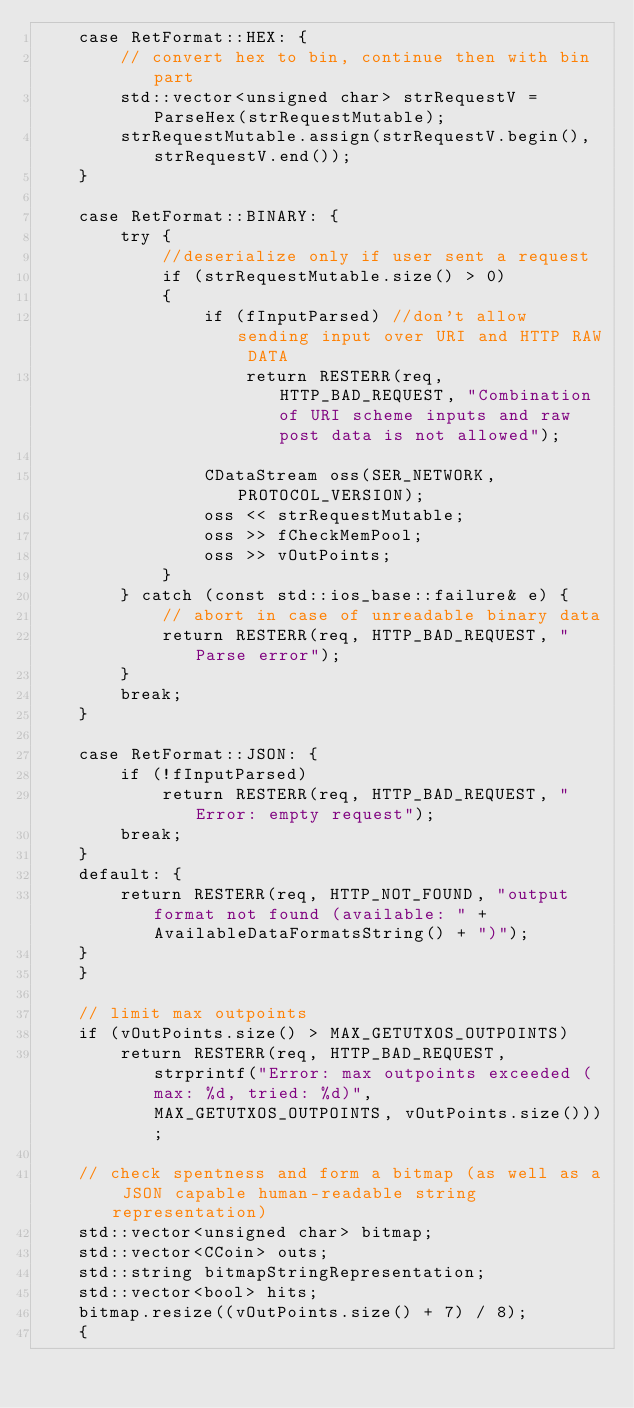<code> <loc_0><loc_0><loc_500><loc_500><_C++_>    case RetFormat::HEX: {
        // convert hex to bin, continue then with bin part
        std::vector<unsigned char> strRequestV = ParseHex(strRequestMutable);
        strRequestMutable.assign(strRequestV.begin(), strRequestV.end());
    }

    case RetFormat::BINARY: {
        try {
            //deserialize only if user sent a request
            if (strRequestMutable.size() > 0)
            {
                if (fInputParsed) //don't allow sending input over URI and HTTP RAW DATA
                    return RESTERR(req, HTTP_BAD_REQUEST, "Combination of URI scheme inputs and raw post data is not allowed");

                CDataStream oss(SER_NETWORK, PROTOCOL_VERSION);
                oss << strRequestMutable;
                oss >> fCheckMemPool;
                oss >> vOutPoints;
            }
        } catch (const std::ios_base::failure& e) {
            // abort in case of unreadable binary data
            return RESTERR(req, HTTP_BAD_REQUEST, "Parse error");
        }
        break;
    }

    case RetFormat::JSON: {
        if (!fInputParsed)
            return RESTERR(req, HTTP_BAD_REQUEST, "Error: empty request");
        break;
    }
    default: {
        return RESTERR(req, HTTP_NOT_FOUND, "output format not found (available: " + AvailableDataFormatsString() + ")");
    }
    }

    // limit max outpoints
    if (vOutPoints.size() > MAX_GETUTXOS_OUTPOINTS)
        return RESTERR(req, HTTP_BAD_REQUEST, strprintf("Error: max outpoints exceeded (max: %d, tried: %d)", MAX_GETUTXOS_OUTPOINTS, vOutPoints.size()));

    // check spentness and form a bitmap (as well as a JSON capable human-readable string representation)
    std::vector<unsigned char> bitmap;
    std::vector<CCoin> outs;
    std::string bitmapStringRepresentation;
    std::vector<bool> hits;
    bitmap.resize((vOutPoints.size() + 7) / 8);
    {</code> 